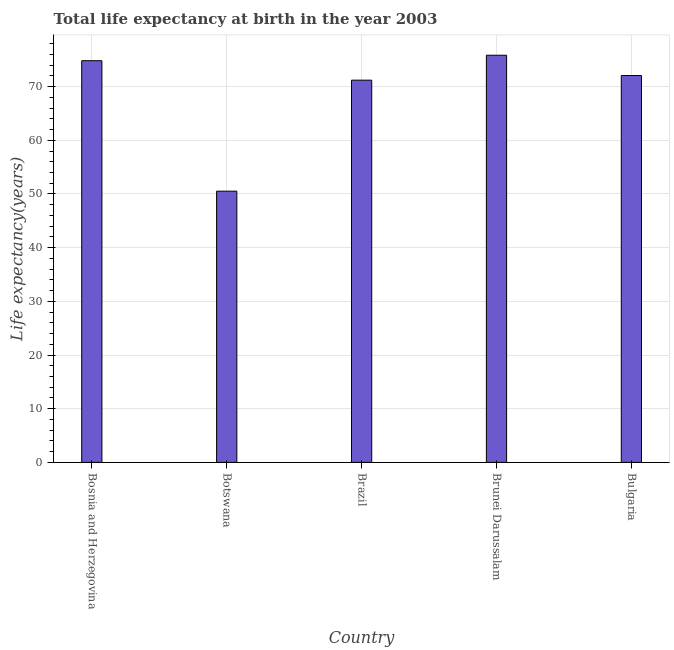What is the title of the graph?
Provide a short and direct response. Total life expectancy at birth in the year 2003. What is the label or title of the Y-axis?
Your response must be concise. Life expectancy(years). What is the life expectancy at birth in Brazil?
Your response must be concise. 71.2. Across all countries, what is the maximum life expectancy at birth?
Offer a very short reply. 75.85. Across all countries, what is the minimum life expectancy at birth?
Your response must be concise. 50.52. In which country was the life expectancy at birth maximum?
Keep it short and to the point. Brunei Darussalam. In which country was the life expectancy at birth minimum?
Ensure brevity in your answer.  Botswana. What is the sum of the life expectancy at birth?
Provide a succinct answer. 344.46. What is the difference between the life expectancy at birth in Bosnia and Herzegovina and Botswana?
Give a very brief answer. 24.3. What is the average life expectancy at birth per country?
Your answer should be compact. 68.89. What is the median life expectancy at birth?
Make the answer very short. 72.07. In how many countries, is the life expectancy at birth greater than 66 years?
Make the answer very short. 4. What is the ratio of the life expectancy at birth in Botswana to that in Brunei Darussalam?
Your answer should be very brief. 0.67. Is the life expectancy at birth in Botswana less than that in Brazil?
Provide a short and direct response. Yes. What is the difference between the highest and the second highest life expectancy at birth?
Your response must be concise. 1.02. What is the difference between the highest and the lowest life expectancy at birth?
Keep it short and to the point. 25.32. In how many countries, is the life expectancy at birth greater than the average life expectancy at birth taken over all countries?
Provide a succinct answer. 4. How many countries are there in the graph?
Offer a terse response. 5. Are the values on the major ticks of Y-axis written in scientific E-notation?
Make the answer very short. No. What is the Life expectancy(years) of Bosnia and Herzegovina?
Ensure brevity in your answer.  74.82. What is the Life expectancy(years) of Botswana?
Make the answer very short. 50.52. What is the Life expectancy(years) in Brazil?
Keep it short and to the point. 71.2. What is the Life expectancy(years) of Brunei Darussalam?
Make the answer very short. 75.85. What is the Life expectancy(years) in Bulgaria?
Offer a very short reply. 72.07. What is the difference between the Life expectancy(years) in Bosnia and Herzegovina and Botswana?
Give a very brief answer. 24.3. What is the difference between the Life expectancy(years) in Bosnia and Herzegovina and Brazil?
Give a very brief answer. 3.62. What is the difference between the Life expectancy(years) in Bosnia and Herzegovina and Brunei Darussalam?
Keep it short and to the point. -1.02. What is the difference between the Life expectancy(years) in Bosnia and Herzegovina and Bulgaria?
Ensure brevity in your answer.  2.76. What is the difference between the Life expectancy(years) in Botswana and Brazil?
Provide a short and direct response. -20.68. What is the difference between the Life expectancy(years) in Botswana and Brunei Darussalam?
Make the answer very short. -25.32. What is the difference between the Life expectancy(years) in Botswana and Bulgaria?
Ensure brevity in your answer.  -21.54. What is the difference between the Life expectancy(years) in Brazil and Brunei Darussalam?
Your answer should be compact. -4.64. What is the difference between the Life expectancy(years) in Brazil and Bulgaria?
Your answer should be compact. -0.86. What is the difference between the Life expectancy(years) in Brunei Darussalam and Bulgaria?
Keep it short and to the point. 3.78. What is the ratio of the Life expectancy(years) in Bosnia and Herzegovina to that in Botswana?
Offer a terse response. 1.48. What is the ratio of the Life expectancy(years) in Bosnia and Herzegovina to that in Brazil?
Provide a short and direct response. 1.05. What is the ratio of the Life expectancy(years) in Bosnia and Herzegovina to that in Brunei Darussalam?
Provide a succinct answer. 0.99. What is the ratio of the Life expectancy(years) in Bosnia and Herzegovina to that in Bulgaria?
Give a very brief answer. 1.04. What is the ratio of the Life expectancy(years) in Botswana to that in Brazil?
Your answer should be very brief. 0.71. What is the ratio of the Life expectancy(years) in Botswana to that in Brunei Darussalam?
Give a very brief answer. 0.67. What is the ratio of the Life expectancy(years) in Botswana to that in Bulgaria?
Provide a succinct answer. 0.7. What is the ratio of the Life expectancy(years) in Brazil to that in Brunei Darussalam?
Offer a terse response. 0.94. What is the ratio of the Life expectancy(years) in Brunei Darussalam to that in Bulgaria?
Give a very brief answer. 1.05. 